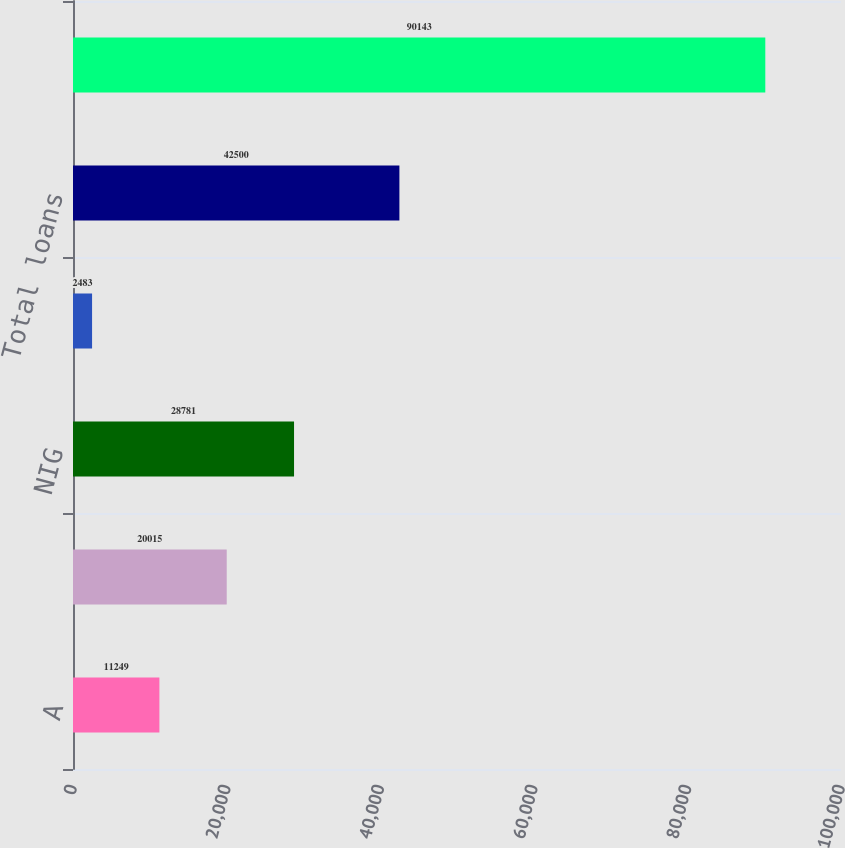Convert chart. <chart><loc_0><loc_0><loc_500><loc_500><bar_chart><fcel>A<fcel>BBB<fcel>NIG<fcel>Unrated 2<fcel>Total loans<fcel>Total lending commitments<nl><fcel>11249<fcel>20015<fcel>28781<fcel>2483<fcel>42500<fcel>90143<nl></chart> 